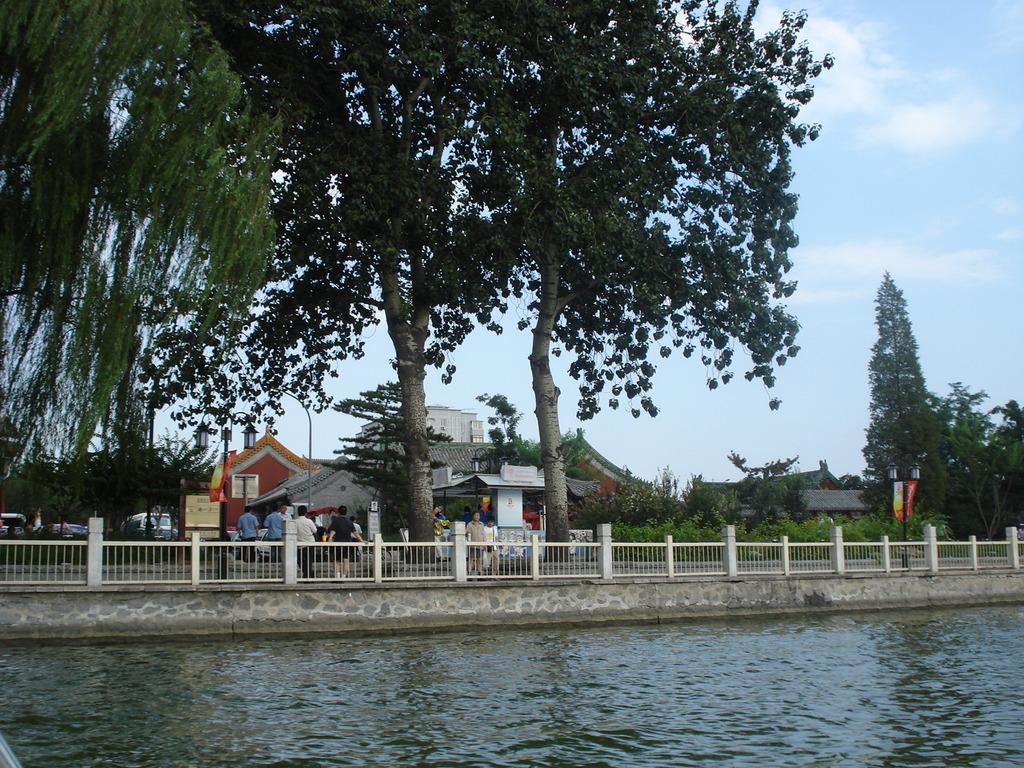How would you summarize this image in a sentence or two? In this image, there are trees, buildings, vehicles, street lights and a group of people. At the bottom of the image, I can see water and iron grilles. In the background, there is the sky. 